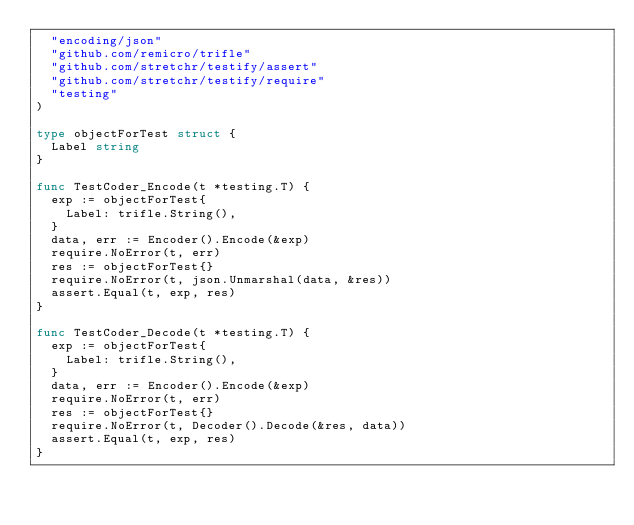Convert code to text. <code><loc_0><loc_0><loc_500><loc_500><_Go_>	"encoding/json"
	"github.com/remicro/trifle"
	"github.com/stretchr/testify/assert"
	"github.com/stretchr/testify/require"
	"testing"
)

type objectForTest struct {
	Label string
}

func TestCoder_Encode(t *testing.T) {
	exp := objectForTest{
		Label: trifle.String(),
	}
	data, err := Encoder().Encode(&exp)
	require.NoError(t, err)
	res := objectForTest{}
	require.NoError(t, json.Unmarshal(data, &res))
	assert.Equal(t, exp, res)
}

func TestCoder_Decode(t *testing.T) {
	exp := objectForTest{
		Label: trifle.String(),
	}
	data, err := Encoder().Encode(&exp)
	require.NoError(t, err)
	res := objectForTest{}
	require.NoError(t, Decoder().Decode(&res, data))
	assert.Equal(t, exp, res)
}
</code> 